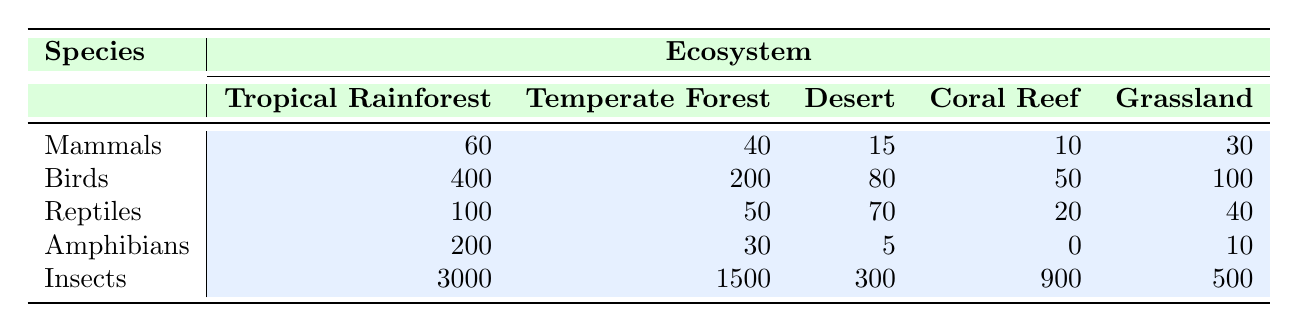What is the total number of species in the Tropical Rainforest? To find the total species in the Tropical Rainforest, sum all species numbers: Mammals (60) + Birds (400) + Reptiles (100) + Amphibians (200) + Insects (3000) = 3860.
Answer: 3860 What is the average number of Mammals across all ecosystems? There are 5 ecosystems listed, and the number of Mammals is: 60 (Tropical Rainforest) + 40 (Temperate Forest) + 15 (Desert) + 10 (Coral Reef) + 30 (Grassland) = 155. The average is 155 divided by 5, resulting in 31.
Answer: 31 Is the number of Birds greater in the Tropical Rainforest than in the Temperate Forest? The number of Birds in the Tropical Rainforest is 400, while in the Temperate Forest it is 200. Since 400 is greater than 200, the statement is true.
Answer: Yes Which ecosystem has the highest number of Insects? Looking at the Insect column, the highest number is found in the Tropical Rainforest with 3000 Insects, which exceeds the numbers in the other ecosystems.
Answer: Tropical Rainforest What is the difference in the number of Reptiles between the Desert and Coral Reef ecosystems? The number of Reptiles in the Desert is 70, while in the Coral Reef it is 20. The difference is 70 - 20 = 50.
Answer: 50 How many Amphibians are present in both the Desert and Coral Reef ecosystems combined? To find the total number of Amphibians, add the counts from both ecosystems: Desert (5) + Coral Reef (0) = 5.
Answer: 5 Which ecosystem has the lowest number of Mammals? Reviewing the Mammals row, the ecosystem with the lowest count is Coral Reef with only 10 Mammals.
Answer: Coral Reef How many total species are present in Grassland? To find the total in Grassland, sum all species: Mammals (30) + Birds (100) + Reptiles (40) + Amphibians (10) + Insects (500) = 680.
Answer: 680 Does the Temperate Forest have more Reptiles than the Coral Reef? The number of Reptiles in the Temperate Forest is 50, and in the Coral Reef, it is 20. Since 50 is greater than 20, the statement is true.
Answer: Yes 